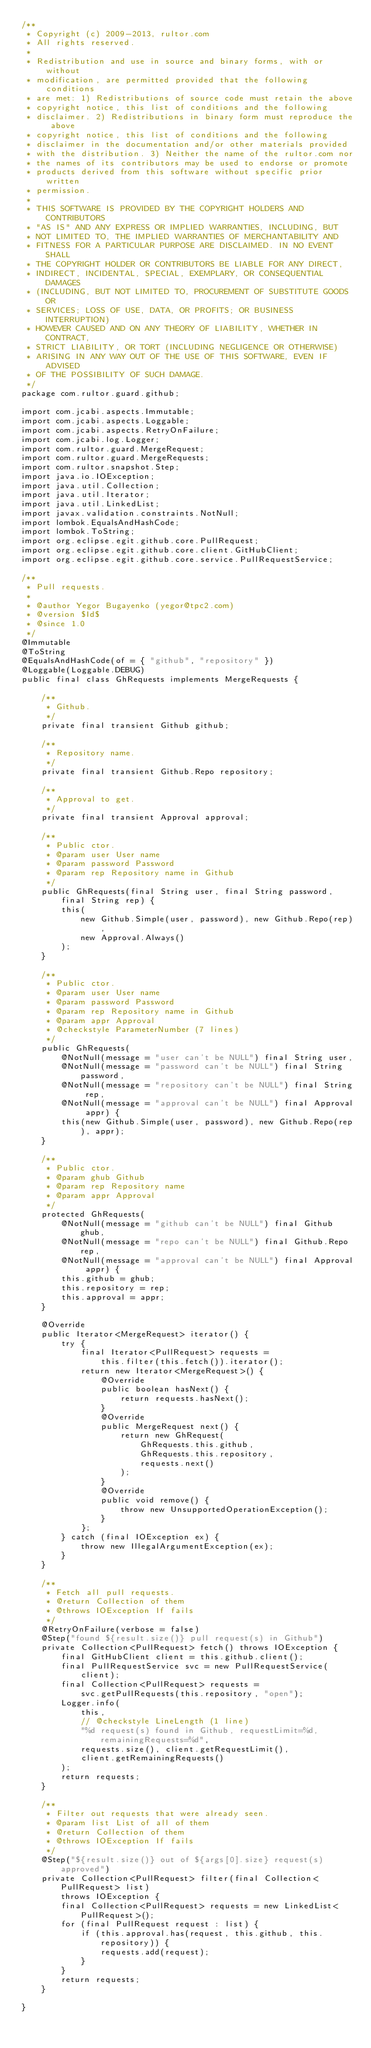<code> <loc_0><loc_0><loc_500><loc_500><_Java_>/**
 * Copyright (c) 2009-2013, rultor.com
 * All rights reserved.
 *
 * Redistribution and use in source and binary forms, with or without
 * modification, are permitted provided that the following conditions
 * are met: 1) Redistributions of source code must retain the above
 * copyright notice, this list of conditions and the following
 * disclaimer. 2) Redistributions in binary form must reproduce the above
 * copyright notice, this list of conditions and the following
 * disclaimer in the documentation and/or other materials provided
 * with the distribution. 3) Neither the name of the rultor.com nor
 * the names of its contributors may be used to endorse or promote
 * products derived from this software without specific prior written
 * permission.
 *
 * THIS SOFTWARE IS PROVIDED BY THE COPYRIGHT HOLDERS AND CONTRIBUTORS
 * "AS IS" AND ANY EXPRESS OR IMPLIED WARRANTIES, INCLUDING, BUT
 * NOT LIMITED TO, THE IMPLIED WARRANTIES OF MERCHANTABILITY AND
 * FITNESS FOR A PARTICULAR PURPOSE ARE DISCLAIMED. IN NO EVENT SHALL
 * THE COPYRIGHT HOLDER OR CONTRIBUTORS BE LIABLE FOR ANY DIRECT,
 * INDIRECT, INCIDENTAL, SPECIAL, EXEMPLARY, OR CONSEQUENTIAL DAMAGES
 * (INCLUDING, BUT NOT LIMITED TO, PROCUREMENT OF SUBSTITUTE GOODS OR
 * SERVICES; LOSS OF USE, DATA, OR PROFITS; OR BUSINESS INTERRUPTION)
 * HOWEVER CAUSED AND ON ANY THEORY OF LIABILITY, WHETHER IN CONTRACT,
 * STRICT LIABILITY, OR TORT (INCLUDING NEGLIGENCE OR OTHERWISE)
 * ARISING IN ANY WAY OUT OF THE USE OF THIS SOFTWARE, EVEN IF ADVISED
 * OF THE POSSIBILITY OF SUCH DAMAGE.
 */
package com.rultor.guard.github;

import com.jcabi.aspects.Immutable;
import com.jcabi.aspects.Loggable;
import com.jcabi.aspects.RetryOnFailure;
import com.jcabi.log.Logger;
import com.rultor.guard.MergeRequest;
import com.rultor.guard.MergeRequests;
import com.rultor.snapshot.Step;
import java.io.IOException;
import java.util.Collection;
import java.util.Iterator;
import java.util.LinkedList;
import javax.validation.constraints.NotNull;
import lombok.EqualsAndHashCode;
import lombok.ToString;
import org.eclipse.egit.github.core.PullRequest;
import org.eclipse.egit.github.core.client.GitHubClient;
import org.eclipse.egit.github.core.service.PullRequestService;

/**
 * Pull requests.
 *
 * @author Yegor Bugayenko (yegor@tpc2.com)
 * @version $Id$
 * @since 1.0
 */
@Immutable
@ToString
@EqualsAndHashCode(of = { "github", "repository" })
@Loggable(Loggable.DEBUG)
public final class GhRequests implements MergeRequests {

    /**
     * Github.
     */
    private final transient Github github;

    /**
     * Repository name.
     */
    private final transient Github.Repo repository;

    /**
     * Approval to get.
     */
    private final transient Approval approval;

    /**
     * Public ctor.
     * @param user User name
     * @param password Password
     * @param rep Repository name in Github
     */
    public GhRequests(final String user, final String password,
        final String rep) {
        this(
            new Github.Simple(user, password), new Github.Repo(rep),
            new Approval.Always()
        );
    }

    /**
     * Public ctor.
     * @param user User name
     * @param password Password
     * @param rep Repository name in Github
     * @param appr Approval
     * @checkstyle ParameterNumber (7 lines)
     */
    public GhRequests(
        @NotNull(message = "user can't be NULL") final String user,
        @NotNull(message = "password can't be NULL") final String password,
        @NotNull(message = "repository can't be NULL") final String rep,
        @NotNull(message = "approval can't be NULL") final Approval appr) {
        this(new Github.Simple(user, password), new Github.Repo(rep), appr);
    }

    /**
     * Public ctor.
     * @param ghub Github
     * @param rep Repository name
     * @param appr Approval
     */
    protected GhRequests(
        @NotNull(message = "github can't be NULL") final Github ghub,
        @NotNull(message = "repo can't be NULL") final Github.Repo rep,
        @NotNull(message = "approval can't be NULL") final Approval appr) {
        this.github = ghub;
        this.repository = rep;
        this.approval = appr;
    }

    @Override
    public Iterator<MergeRequest> iterator() {
        try {
            final Iterator<PullRequest> requests =
                this.filter(this.fetch()).iterator();
            return new Iterator<MergeRequest>() {
                @Override
                public boolean hasNext() {
                    return requests.hasNext();
                }
                @Override
                public MergeRequest next() {
                    return new GhRequest(
                        GhRequests.this.github,
                        GhRequests.this.repository,
                        requests.next()
                    );
                }
                @Override
                public void remove() {
                    throw new UnsupportedOperationException();
                }
            };
        } catch (final IOException ex) {
            throw new IllegalArgumentException(ex);
        }
    }

    /**
     * Fetch all pull requests.
     * @return Collection of them
     * @throws IOException If fails
     */
    @RetryOnFailure(verbose = false)
    @Step("found ${result.size()} pull request(s) in Github")
    private Collection<PullRequest> fetch() throws IOException {
        final GitHubClient client = this.github.client();
        final PullRequestService svc = new PullRequestService(client);
        final Collection<PullRequest> requests =
            svc.getPullRequests(this.repository, "open");
        Logger.info(
            this,
            // @checkstyle LineLength (1 line)
            "%d request(s) found in Github, requestLimit=%d, remainingRequests=%d",
            requests.size(), client.getRequestLimit(),
            client.getRemainingRequests()
        );
        return requests;
    }

    /**
     * Filter out requests that were already seen.
     * @param list List of all of them
     * @return Collection of them
     * @throws IOException If fails
     */
    @Step("${result.size()} out of ${args[0].size} request(s) approved")
    private Collection<PullRequest> filter(final Collection<PullRequest> list)
        throws IOException {
        final Collection<PullRequest> requests = new LinkedList<PullRequest>();
        for (final PullRequest request : list) {
            if (this.approval.has(request, this.github, this.repository)) {
                requests.add(request);
            }
        }
        return requests;
    }

}
</code> 